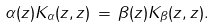<formula> <loc_0><loc_0><loc_500><loc_500>\alpha ( z ) K _ { \alpha } ( z , z ) \, = \, \beta ( z ) K _ { \beta } ( z , z ) .</formula> 